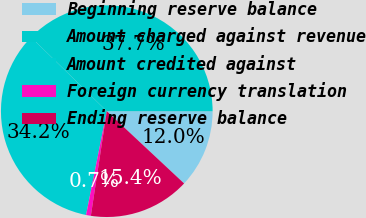<chart> <loc_0><loc_0><loc_500><loc_500><pie_chart><fcel>Beginning reserve balance<fcel>Amount charged against revenue<fcel>Amount credited against<fcel>Foreign currency translation<fcel>Ending reserve balance<nl><fcel>11.95%<fcel>37.68%<fcel>34.19%<fcel>0.73%<fcel>15.44%<nl></chart> 